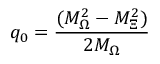<formula> <loc_0><loc_0><loc_500><loc_500>q _ { 0 } = \frac { ( M _ { \Omega } ^ { 2 } - M _ { \Xi } ^ { 2 } ) } { 2 M _ { \Omega } }</formula> 